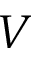Convert formula to latex. <formula><loc_0><loc_0><loc_500><loc_500>V</formula> 